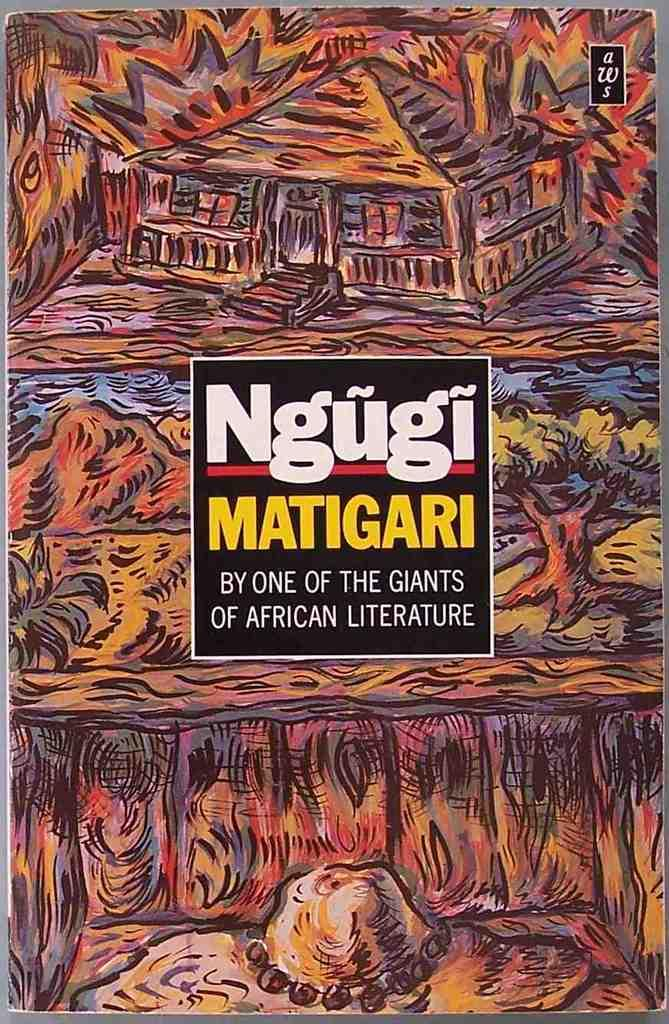<image>
Summarize the visual content of the image. An illustration has the letters aWs printed in the upper corner. 